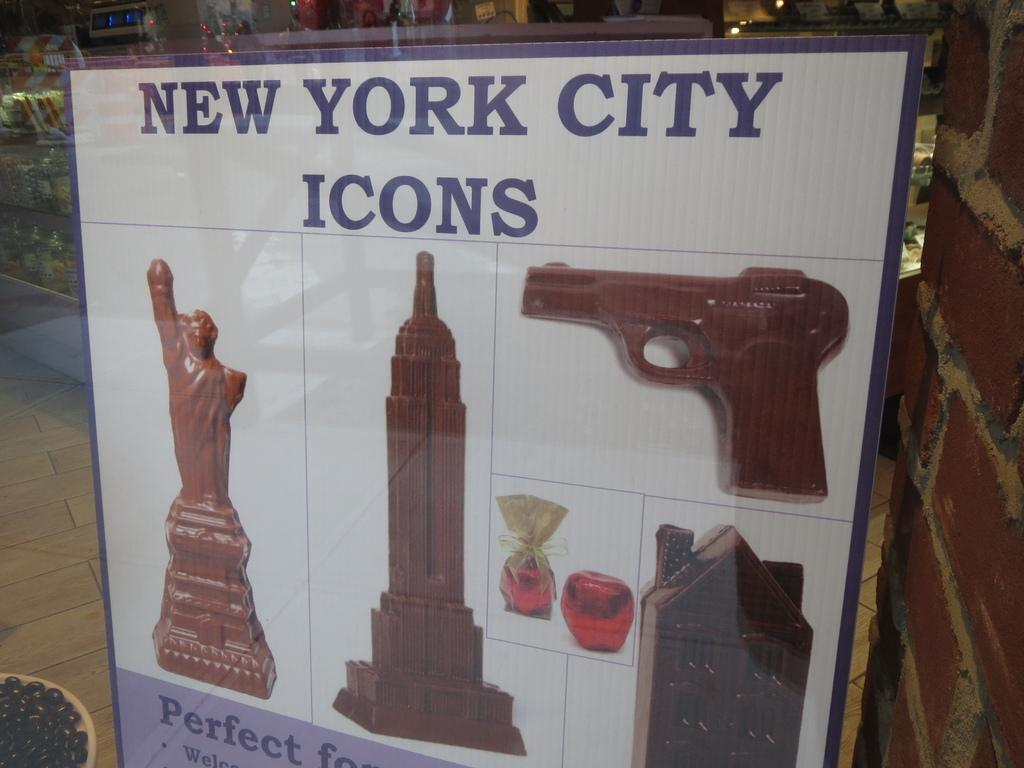<image>
Create a compact narrative representing the image presented. An advertisement shows statues and a hand gun as New York City icons. 